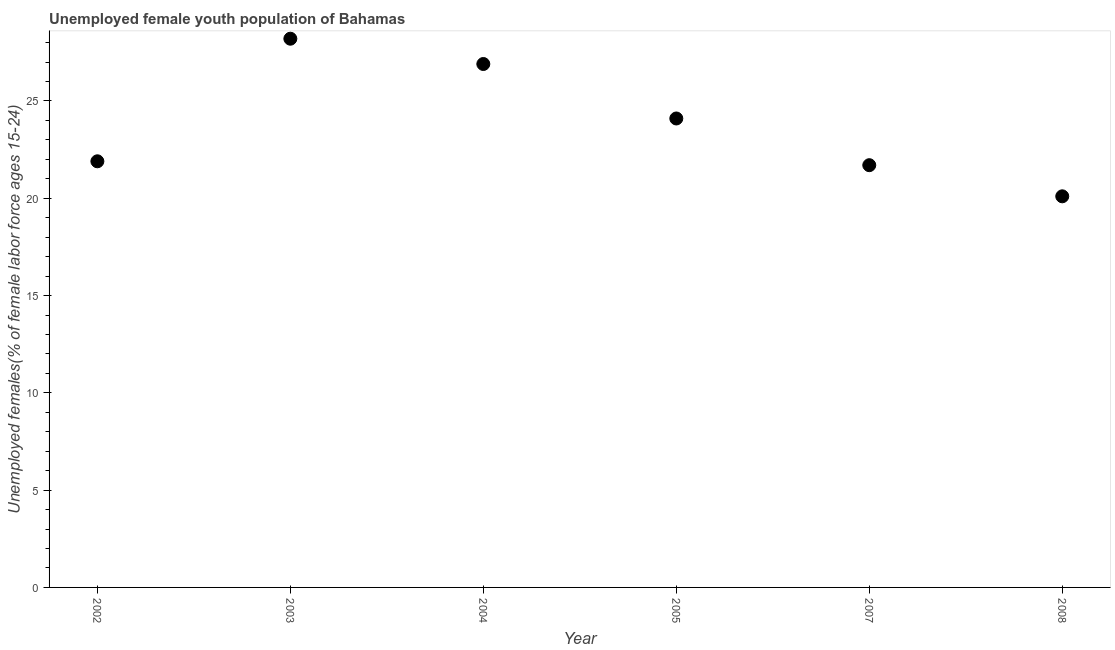What is the unemployed female youth in 2008?
Your answer should be compact. 20.1. Across all years, what is the maximum unemployed female youth?
Your response must be concise. 28.2. Across all years, what is the minimum unemployed female youth?
Provide a succinct answer. 20.1. In which year was the unemployed female youth maximum?
Ensure brevity in your answer.  2003. What is the sum of the unemployed female youth?
Offer a very short reply. 142.9. What is the difference between the unemployed female youth in 2002 and 2008?
Ensure brevity in your answer.  1.8. What is the average unemployed female youth per year?
Keep it short and to the point. 23.82. What is the median unemployed female youth?
Keep it short and to the point. 23. In how many years, is the unemployed female youth greater than 17 %?
Ensure brevity in your answer.  6. Do a majority of the years between 2007 and 2008 (inclusive) have unemployed female youth greater than 19 %?
Your answer should be compact. Yes. What is the ratio of the unemployed female youth in 2004 to that in 2007?
Offer a very short reply. 1.24. Is the difference between the unemployed female youth in 2002 and 2003 greater than the difference between any two years?
Give a very brief answer. No. What is the difference between the highest and the second highest unemployed female youth?
Your answer should be compact. 1.3. What is the difference between the highest and the lowest unemployed female youth?
Ensure brevity in your answer.  8.1. In how many years, is the unemployed female youth greater than the average unemployed female youth taken over all years?
Your answer should be very brief. 3. How many years are there in the graph?
Your answer should be very brief. 6. Does the graph contain any zero values?
Your answer should be compact. No. What is the title of the graph?
Make the answer very short. Unemployed female youth population of Bahamas. What is the label or title of the Y-axis?
Your answer should be very brief. Unemployed females(% of female labor force ages 15-24). What is the Unemployed females(% of female labor force ages 15-24) in 2002?
Your answer should be compact. 21.9. What is the Unemployed females(% of female labor force ages 15-24) in 2003?
Your answer should be very brief. 28.2. What is the Unemployed females(% of female labor force ages 15-24) in 2004?
Your response must be concise. 26.9. What is the Unemployed females(% of female labor force ages 15-24) in 2005?
Your answer should be very brief. 24.1. What is the Unemployed females(% of female labor force ages 15-24) in 2007?
Make the answer very short. 21.7. What is the Unemployed females(% of female labor force ages 15-24) in 2008?
Your answer should be compact. 20.1. What is the difference between the Unemployed females(% of female labor force ages 15-24) in 2002 and 2005?
Keep it short and to the point. -2.2. What is the difference between the Unemployed females(% of female labor force ages 15-24) in 2002 and 2008?
Offer a terse response. 1.8. What is the difference between the Unemployed females(% of female labor force ages 15-24) in 2004 and 2007?
Give a very brief answer. 5.2. What is the difference between the Unemployed females(% of female labor force ages 15-24) in 2004 and 2008?
Your answer should be compact. 6.8. What is the difference between the Unemployed females(% of female labor force ages 15-24) in 2005 and 2007?
Your response must be concise. 2.4. What is the difference between the Unemployed females(% of female labor force ages 15-24) in 2005 and 2008?
Provide a succinct answer. 4. What is the difference between the Unemployed females(% of female labor force ages 15-24) in 2007 and 2008?
Provide a succinct answer. 1.6. What is the ratio of the Unemployed females(% of female labor force ages 15-24) in 2002 to that in 2003?
Keep it short and to the point. 0.78. What is the ratio of the Unemployed females(% of female labor force ages 15-24) in 2002 to that in 2004?
Provide a short and direct response. 0.81. What is the ratio of the Unemployed females(% of female labor force ages 15-24) in 2002 to that in 2005?
Keep it short and to the point. 0.91. What is the ratio of the Unemployed females(% of female labor force ages 15-24) in 2002 to that in 2008?
Provide a succinct answer. 1.09. What is the ratio of the Unemployed females(% of female labor force ages 15-24) in 2003 to that in 2004?
Make the answer very short. 1.05. What is the ratio of the Unemployed females(% of female labor force ages 15-24) in 2003 to that in 2005?
Provide a short and direct response. 1.17. What is the ratio of the Unemployed females(% of female labor force ages 15-24) in 2003 to that in 2008?
Offer a very short reply. 1.4. What is the ratio of the Unemployed females(% of female labor force ages 15-24) in 2004 to that in 2005?
Give a very brief answer. 1.12. What is the ratio of the Unemployed females(% of female labor force ages 15-24) in 2004 to that in 2007?
Your response must be concise. 1.24. What is the ratio of the Unemployed females(% of female labor force ages 15-24) in 2004 to that in 2008?
Your answer should be very brief. 1.34. What is the ratio of the Unemployed females(% of female labor force ages 15-24) in 2005 to that in 2007?
Keep it short and to the point. 1.11. What is the ratio of the Unemployed females(% of female labor force ages 15-24) in 2005 to that in 2008?
Provide a succinct answer. 1.2. 